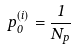Convert formula to latex. <formula><loc_0><loc_0><loc_500><loc_500>p _ { 0 } ^ { ( i ) } = \frac { 1 } { N _ { p } }</formula> 